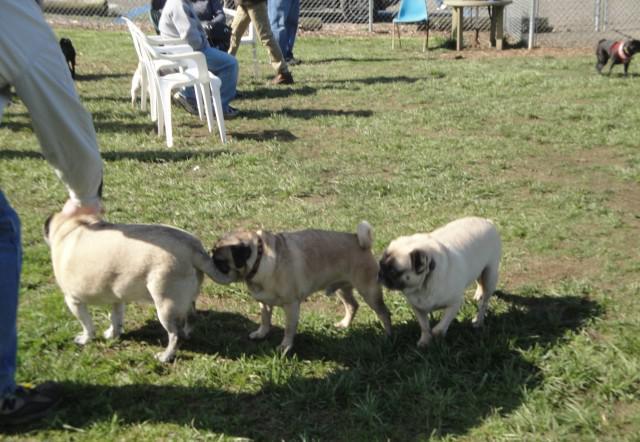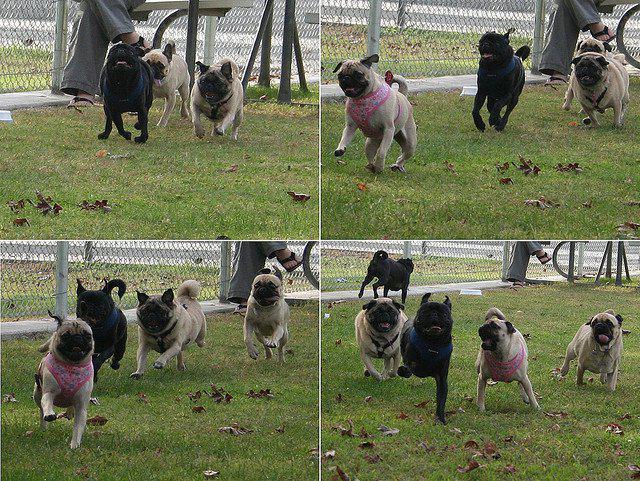The first image is the image on the left, the second image is the image on the right. For the images displayed, is the sentence "At least one image shows a group of pugs running toward the camera on grass." factually correct? Answer yes or no. Yes. 